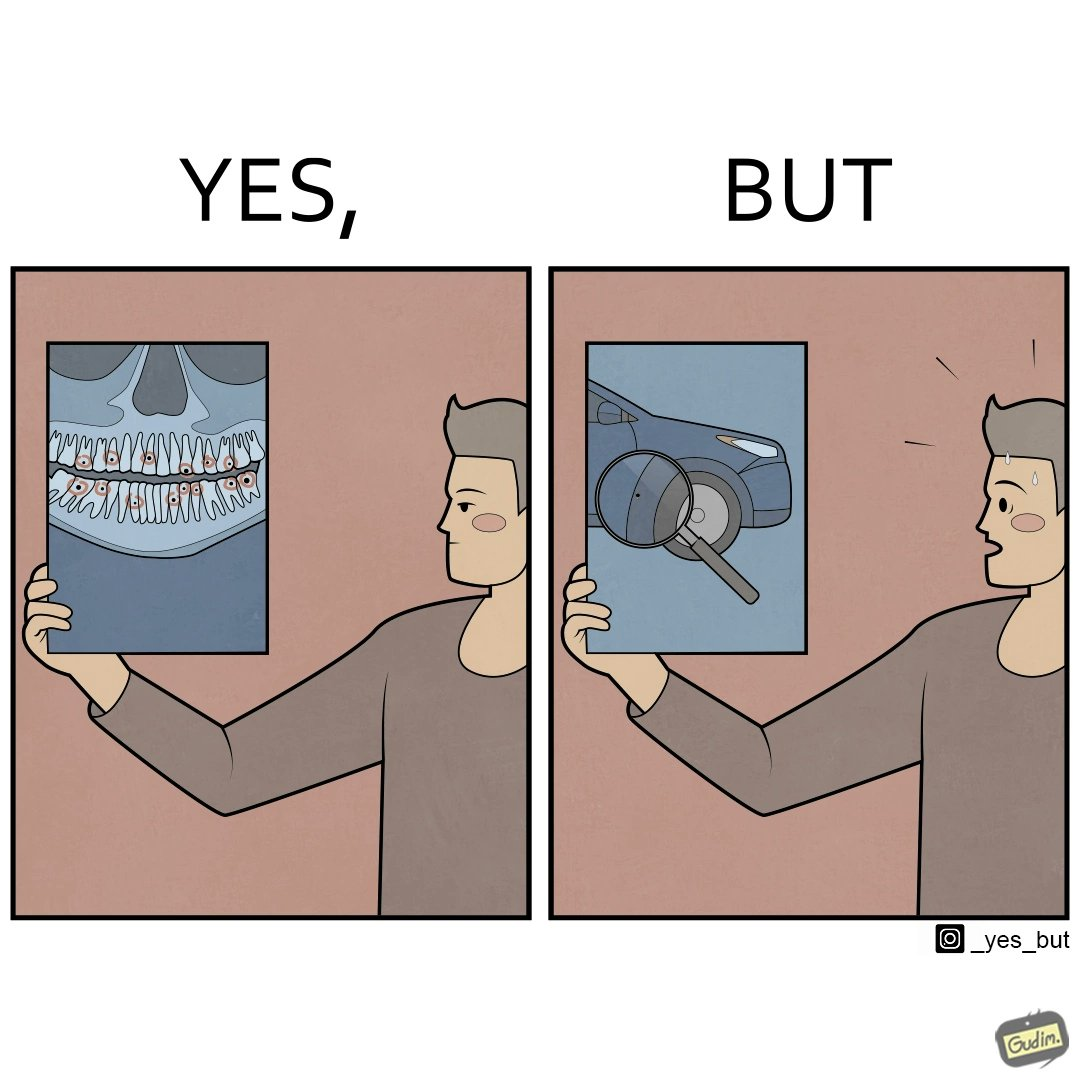Provide a description of this image. The images are funny since they show how people are more worried about small damages to  things they can replace like cars but are not worried about permanent damages to their own health 